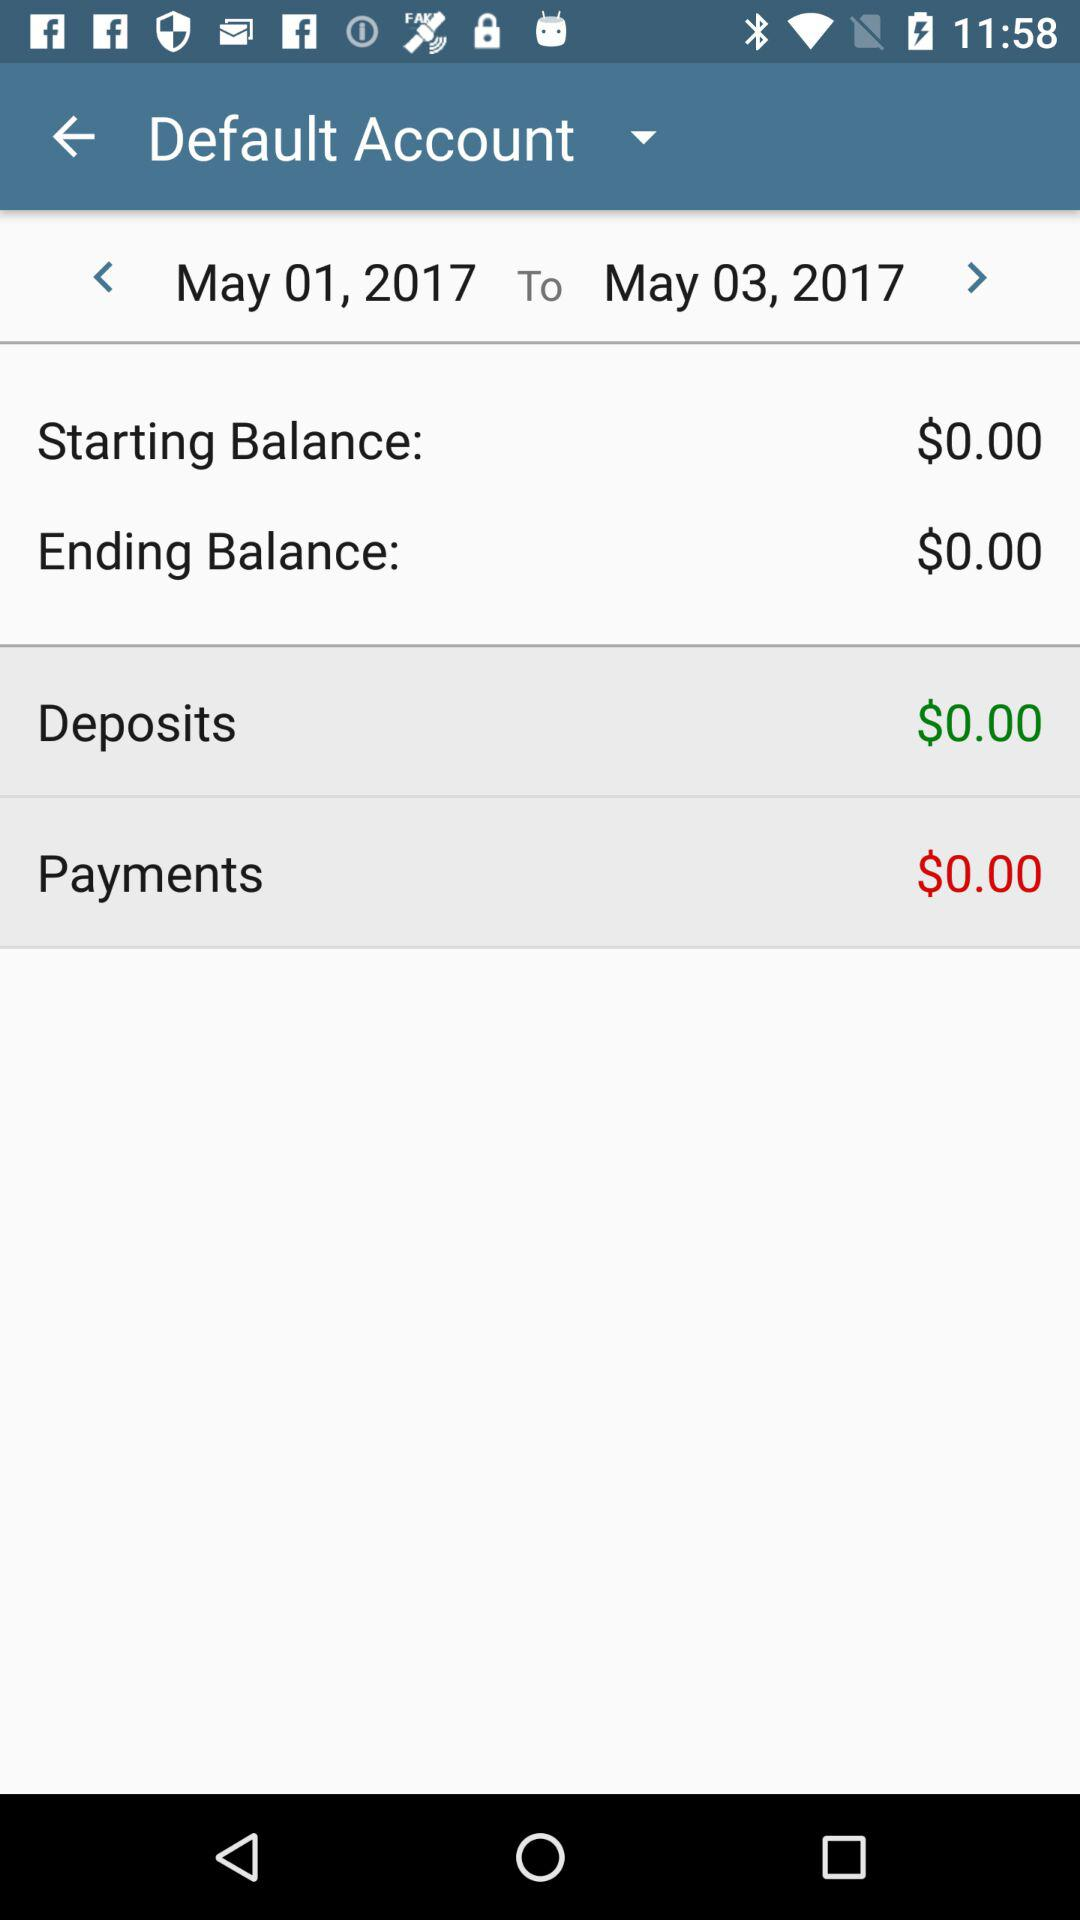What is the selected range of dates? The selected range of dates is from May 1, 2017 to May 3, 2017. 